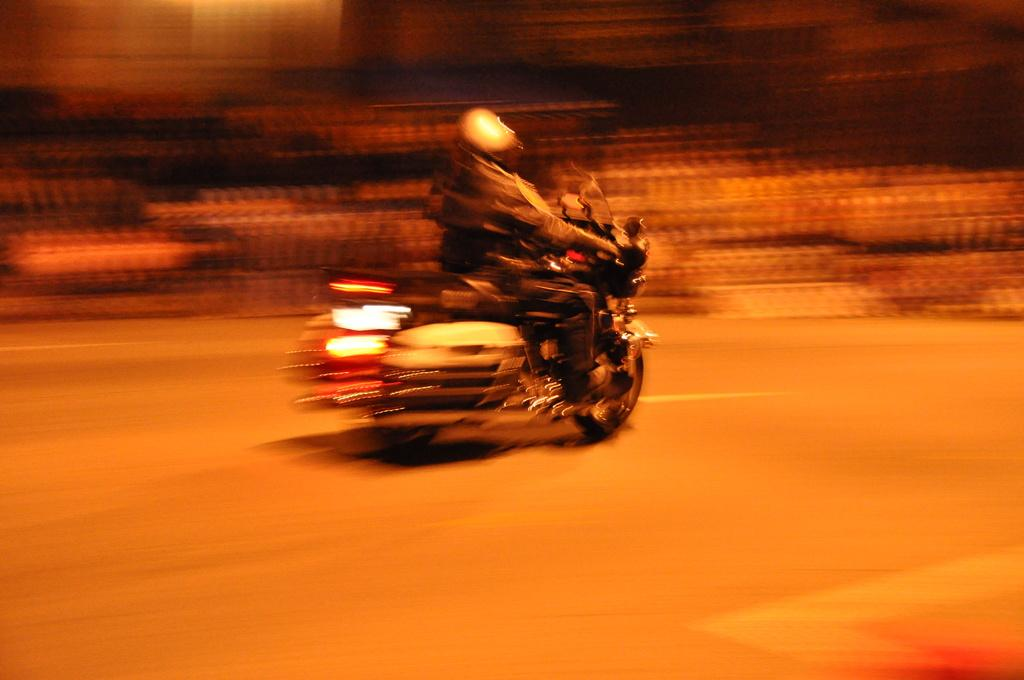What is the main subject of the image? There is a person in the image. What is the person wearing? The person is wearing clothes and a helmet. What activity is the person engaged in? The person is riding a motorbike. Can you describe the background of the image? The background of the image is blurred. What type of gold jewelry is the person wearing in the image? There is no gold jewelry visible in the image; the person is wearing a helmet and clothes. Can you see any deer in the background of the image? There are no deer present in the image; the background is blurred. 